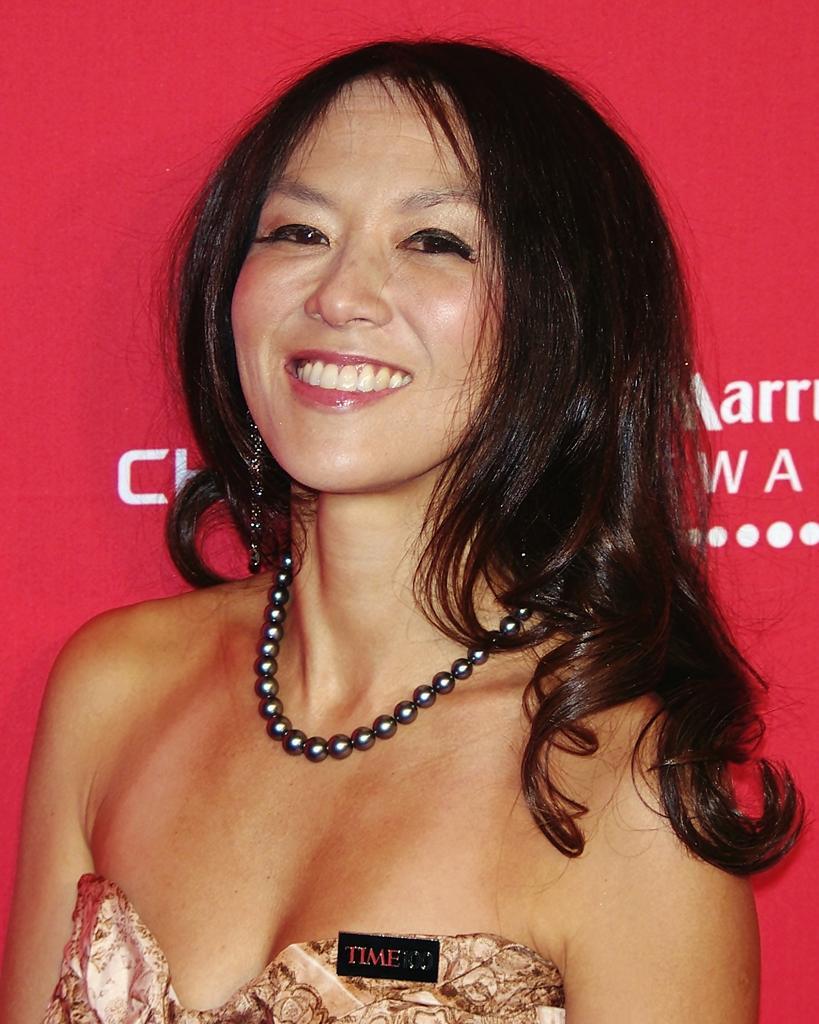Please provide a concise description of this image. In this image we can see a person and behind the person it looks like a banner with text. 